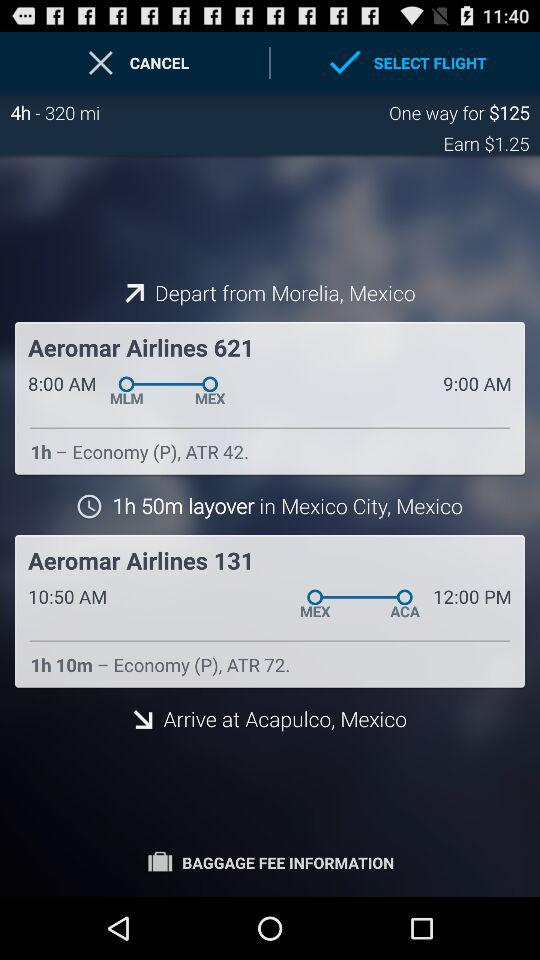What is the departure time from Mexico city? The departure time from Mexico City is 10:50 AM. 